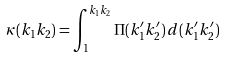Convert formula to latex. <formula><loc_0><loc_0><loc_500><loc_500>\kappa ( k _ { 1 } k _ { 2 } ) = \int _ { 1 } ^ { k _ { 1 } k _ { 2 } } \Pi ( k _ { 1 } ^ { \prime } k _ { 2 } ^ { \prime } ) \, d ( k _ { 1 } ^ { \prime } k _ { 2 } ^ { \prime } )</formula> 